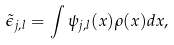<formula> <loc_0><loc_0><loc_500><loc_500>\tilde { \epsilon } _ { j , l } = \int \psi _ { j , l } ( x ) \rho ( x ) d x ,</formula> 